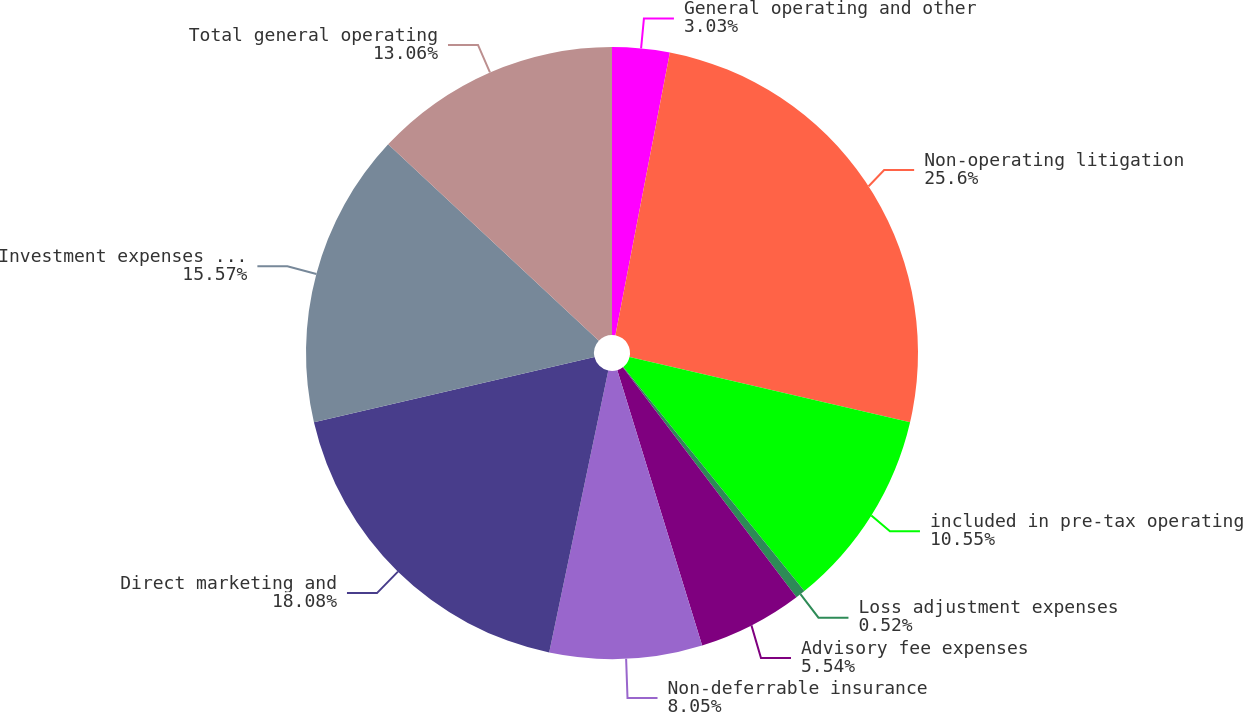<chart> <loc_0><loc_0><loc_500><loc_500><pie_chart><fcel>General operating and other<fcel>Non-operating litigation<fcel>included in pre-tax operating<fcel>Loss adjustment expenses<fcel>Advisory fee expenses<fcel>Non-deferrable insurance<fcel>Direct marketing and<fcel>Investment expenses reported<fcel>Total general operating<nl><fcel>3.03%<fcel>25.6%<fcel>10.55%<fcel>0.52%<fcel>5.54%<fcel>8.05%<fcel>18.08%<fcel>15.57%<fcel>13.06%<nl></chart> 